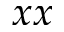Convert formula to latex. <formula><loc_0><loc_0><loc_500><loc_500>x x</formula> 